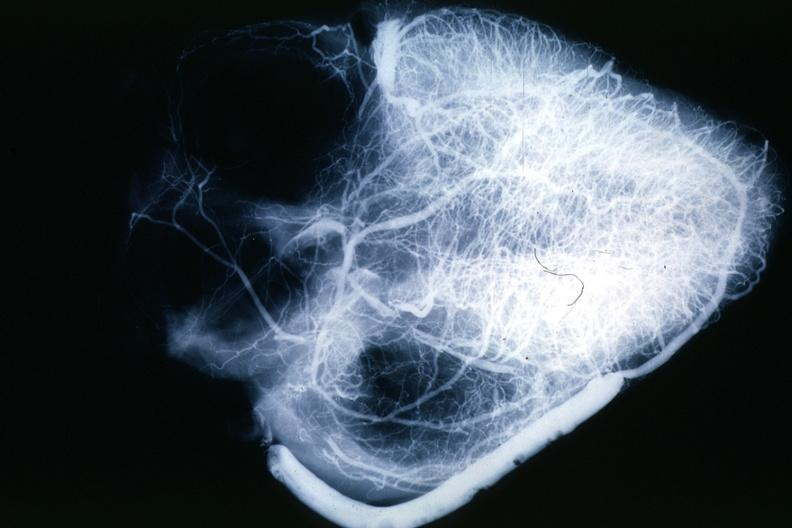what is present?
Answer the question using a single word or phrase. Angiogram saphenous vein bypass graft 